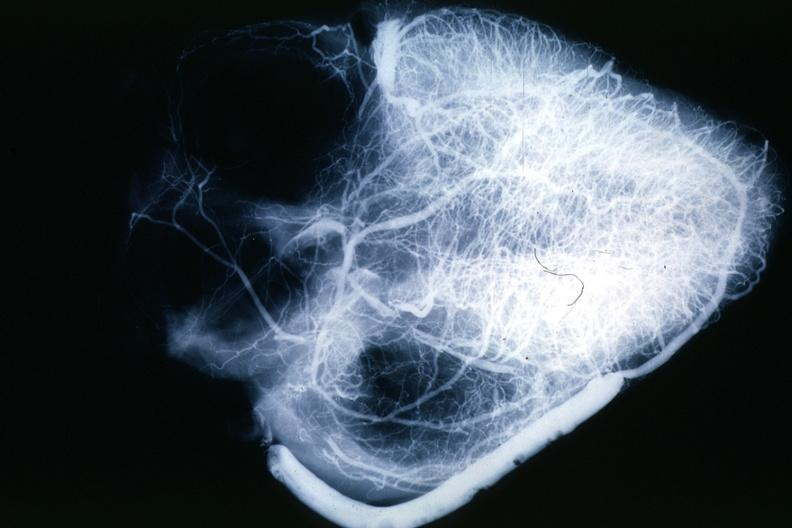what is present?
Answer the question using a single word or phrase. Angiogram saphenous vein bypass graft 